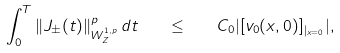Convert formula to latex. <formula><loc_0><loc_0><loc_500><loc_500>\int _ { 0 } ^ { T } \| J _ { \pm } ( t ) \| ^ { p } _ { W ^ { 1 , p } _ { Z } } \, d t \quad \leq \quad C _ { 0 } | [ v _ { 0 } ( x , 0 ) ] _ { | _ { x = 0 } } | ,</formula> 